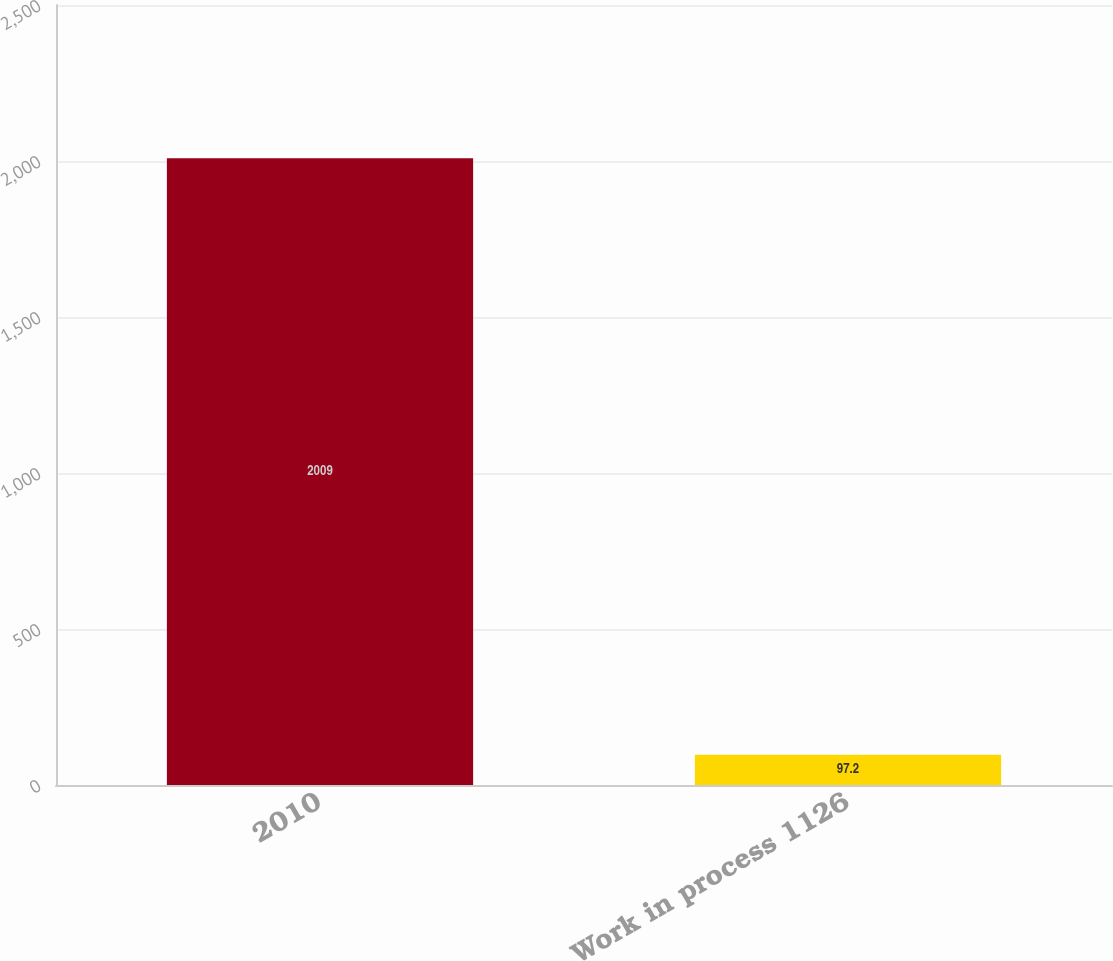Convert chart to OTSL. <chart><loc_0><loc_0><loc_500><loc_500><bar_chart><fcel>2010<fcel>Work in process 1126<nl><fcel>2009<fcel>97.2<nl></chart> 